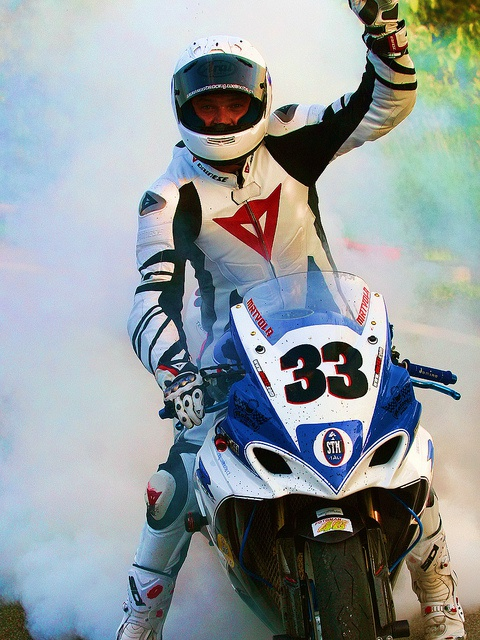Describe the objects in this image and their specific colors. I can see people in lightgray, black, darkgray, and tan tones and motorcycle in lightgray, black, navy, and darkgray tones in this image. 